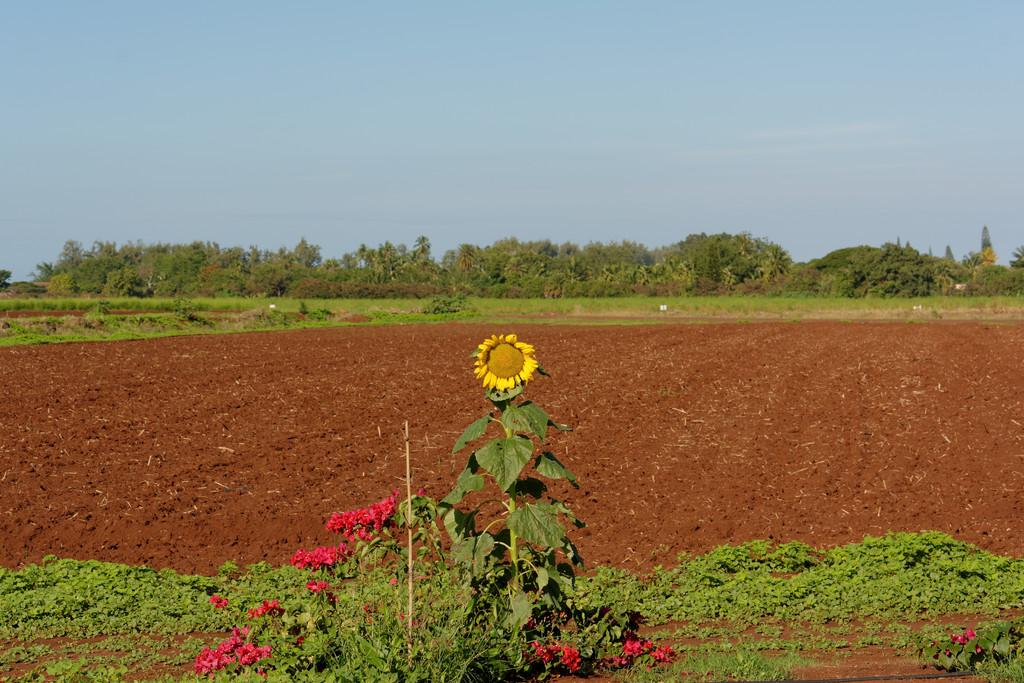What is the main subject of the image? There is a sunflower plant in the middle of the image. What type of landscape is visible behind the sunflower plant? There is farmland behind the sunflower plant. What other natural elements can be seen in the background of the image? There are trees in the background of the image. What is visible above the sunflower plant? The sky is visible above the sunflower plant. What type of powder is sprinkled on the sunflower plant in the image? There is no powder visible on the sunflower plant in the image. How many thumbs can be seen interacting with the sunflower plant in the image? There are no thumbs visible in the image; it is a photograph of a sunflower plant in its natural environment. 